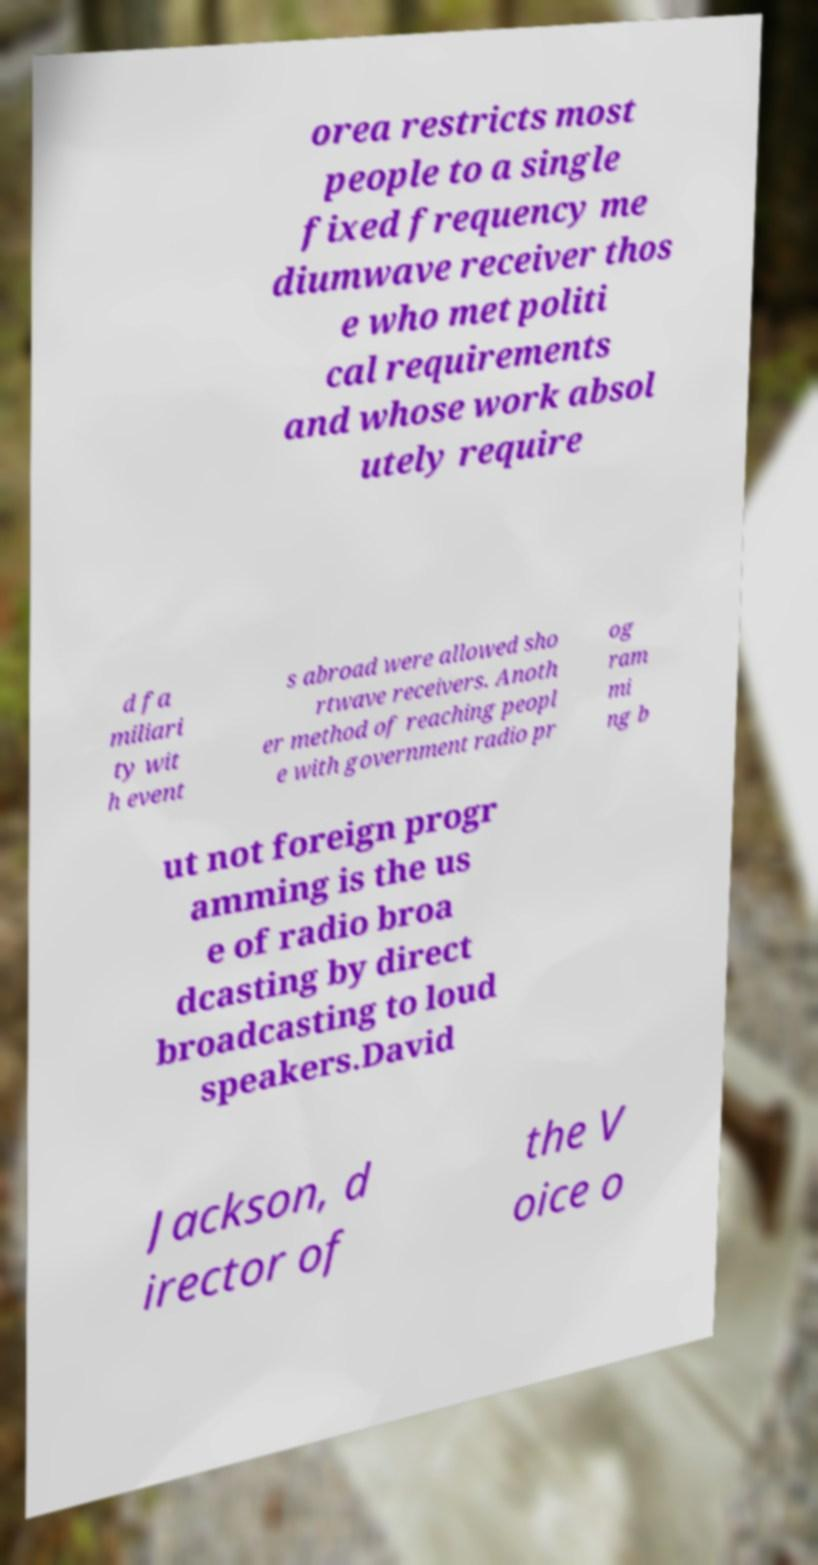There's text embedded in this image that I need extracted. Can you transcribe it verbatim? orea restricts most people to a single fixed frequency me diumwave receiver thos e who met politi cal requirements and whose work absol utely require d fa miliari ty wit h event s abroad were allowed sho rtwave receivers. Anoth er method of reaching peopl e with government radio pr og ram mi ng b ut not foreign progr amming is the us e of radio broa dcasting by direct broadcasting to loud speakers.David Jackson, d irector of the V oice o 